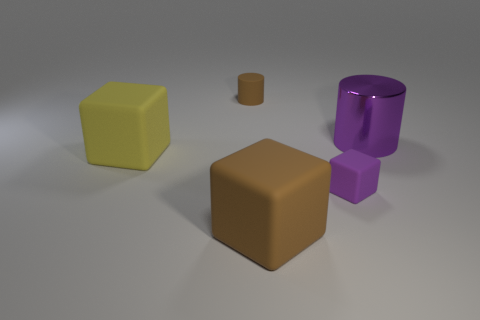Add 2 rubber objects. How many objects exist? 7 Subtract all cylinders. How many objects are left? 3 Subtract 0 purple balls. How many objects are left? 5 Subtract all big gray cylinders. Subtract all tiny purple things. How many objects are left? 4 Add 1 tiny cylinders. How many tiny cylinders are left? 2 Add 2 big brown objects. How many big brown objects exist? 3 